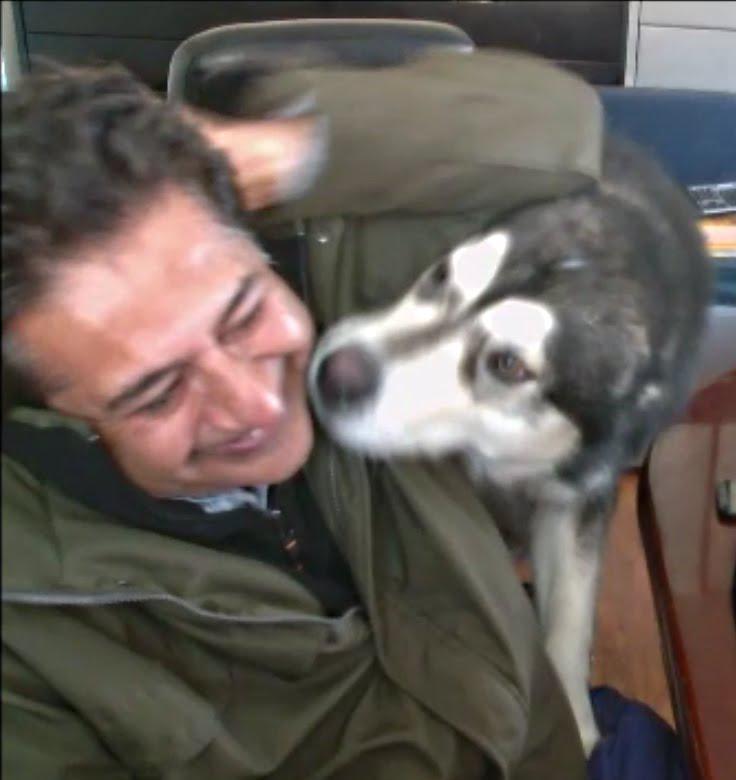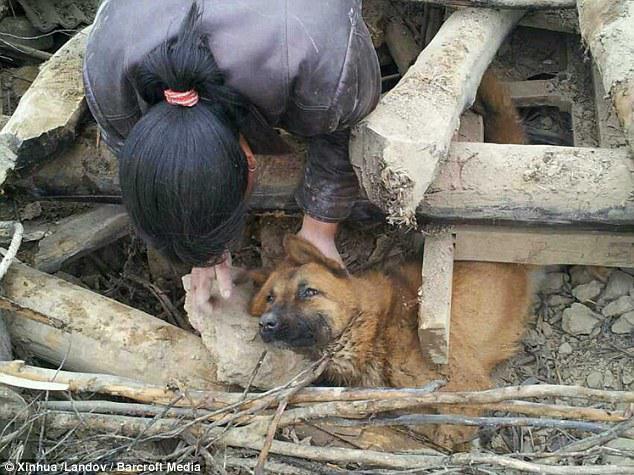The first image is the image on the left, the second image is the image on the right. Analyze the images presented: Is the assertion "There is a person wearing camouflage hugging a dog." valid? Answer yes or no. No. The first image is the image on the left, the second image is the image on the right. Examine the images to the left and right. Is the description "One image shows a person in a pony-tail with head bent toward a dog, and the other image shows a male in an olive jacket with head next to a dog." accurate? Answer yes or no. Yes. 